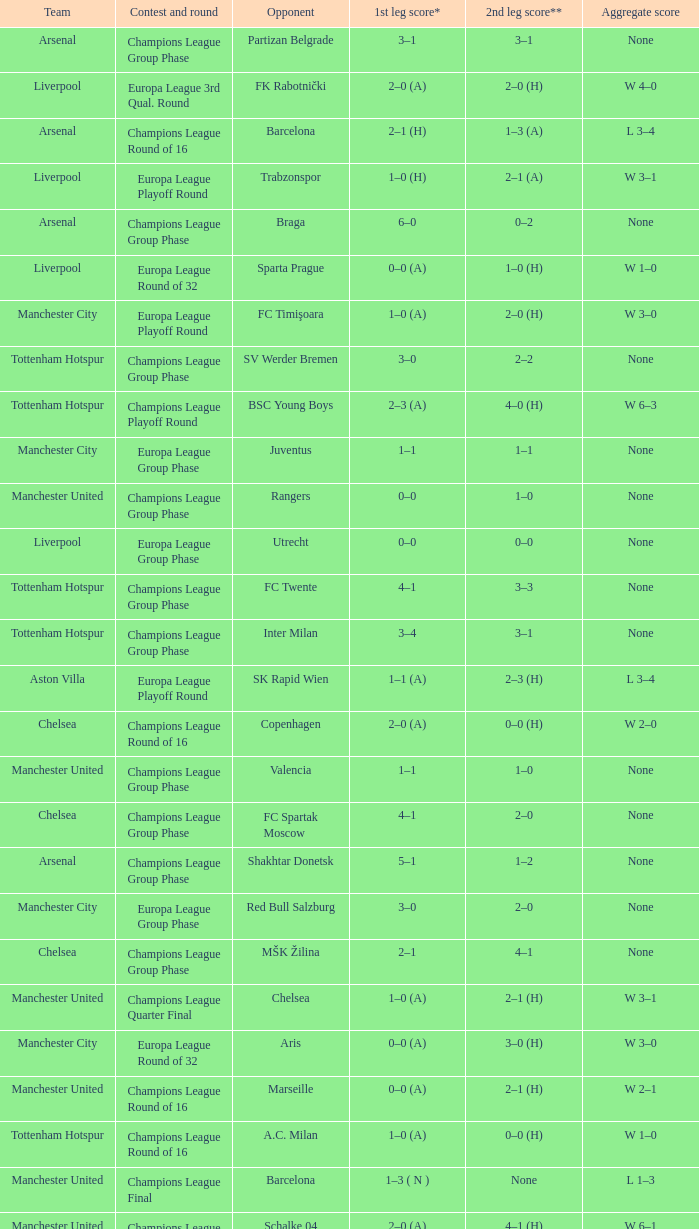What was the score between Marseille and Manchester United on the second leg of the Champions League Round of 16? 2–1 (H). 